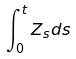Convert formula to latex. <formula><loc_0><loc_0><loc_500><loc_500>\int _ { 0 } ^ { t } Z _ { s } d s</formula> 